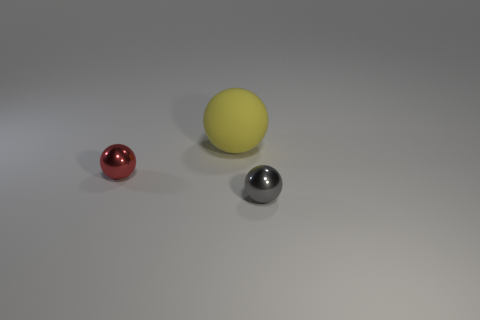What colors are the spheres in the image? The spheres in the image are red, yellow, and silver. 